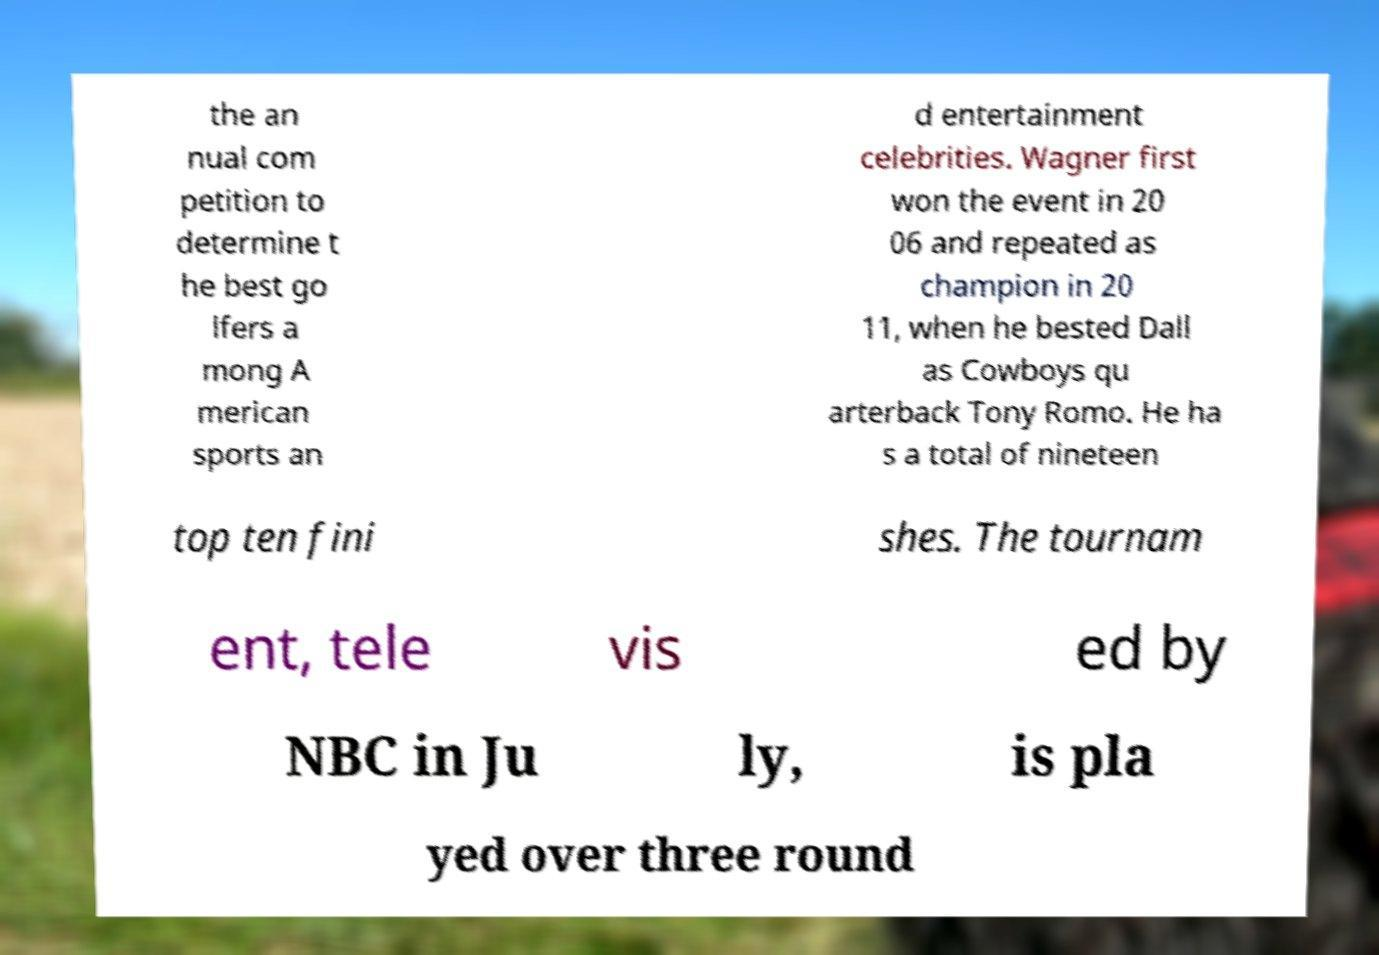Could you assist in decoding the text presented in this image and type it out clearly? the an nual com petition to determine t he best go lfers a mong A merican sports an d entertainment celebrities. Wagner first won the event in 20 06 and repeated as champion in 20 11, when he bested Dall as Cowboys qu arterback Tony Romo. He ha s a total of nineteen top ten fini shes. The tournam ent, tele vis ed by NBC in Ju ly, is pla yed over three round 